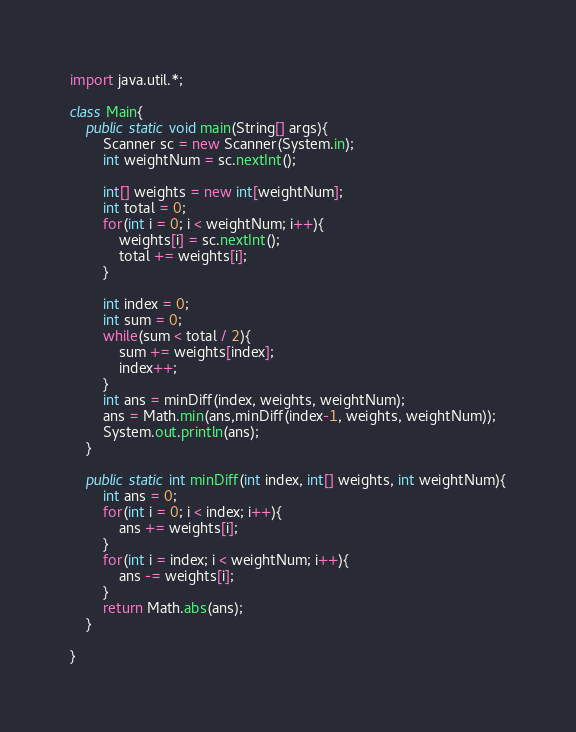Convert code to text. <code><loc_0><loc_0><loc_500><loc_500><_Java_>import java.util.*;

class Main{
    public static void main(String[] args){
        Scanner sc = new Scanner(System.in);
        int weightNum = sc.nextInt();

        int[] weights = new int[weightNum];
        int total = 0;
        for(int i = 0; i < weightNum; i++){
            weights[i] = sc.nextInt();
            total += weights[i];
        }

        int index = 0;
        int sum = 0;
        while(sum < total / 2){
            sum += weights[index];
            index++;
        }
        int ans = minDiff(index, weights, weightNum);
        ans = Math.min(ans,minDiff(index-1, weights, weightNum));
        System.out.println(ans);
    }

    public static int minDiff(int index, int[] weights, int weightNum){
        int ans = 0;
        for(int i = 0; i < index; i++){
            ans += weights[i];
        }
        for(int i = index; i < weightNum; i++){
            ans -= weights[i];
        }
        return Math.abs(ans);
    }

}
</code> 